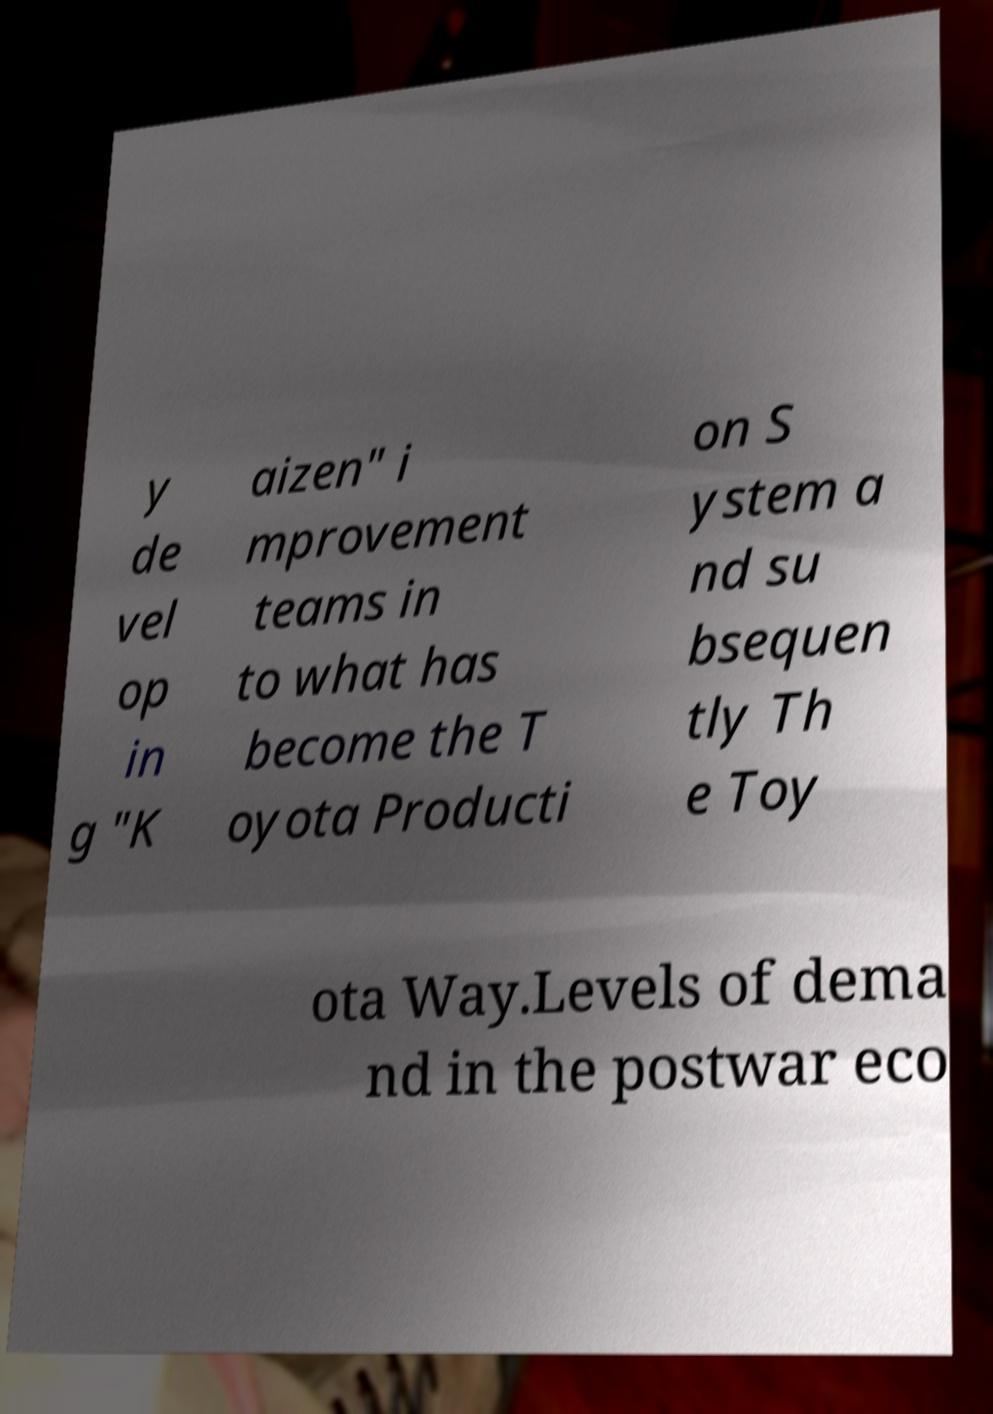Could you assist in decoding the text presented in this image and type it out clearly? y de vel op in g "K aizen" i mprovement teams in to what has become the T oyota Producti on S ystem a nd su bsequen tly Th e Toy ota Way.Levels of dema nd in the postwar eco 